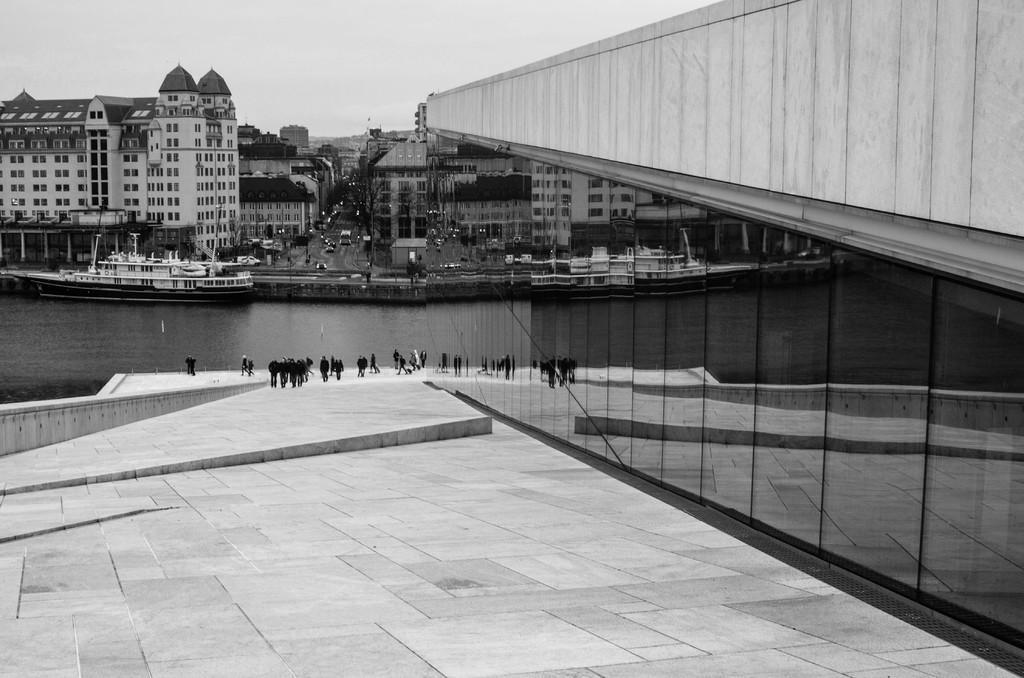Can you describe this image briefly? This is a black and white image. In this image we can see ship, water, persons on the floor, buildings, trees, motor vehicles and sky. 